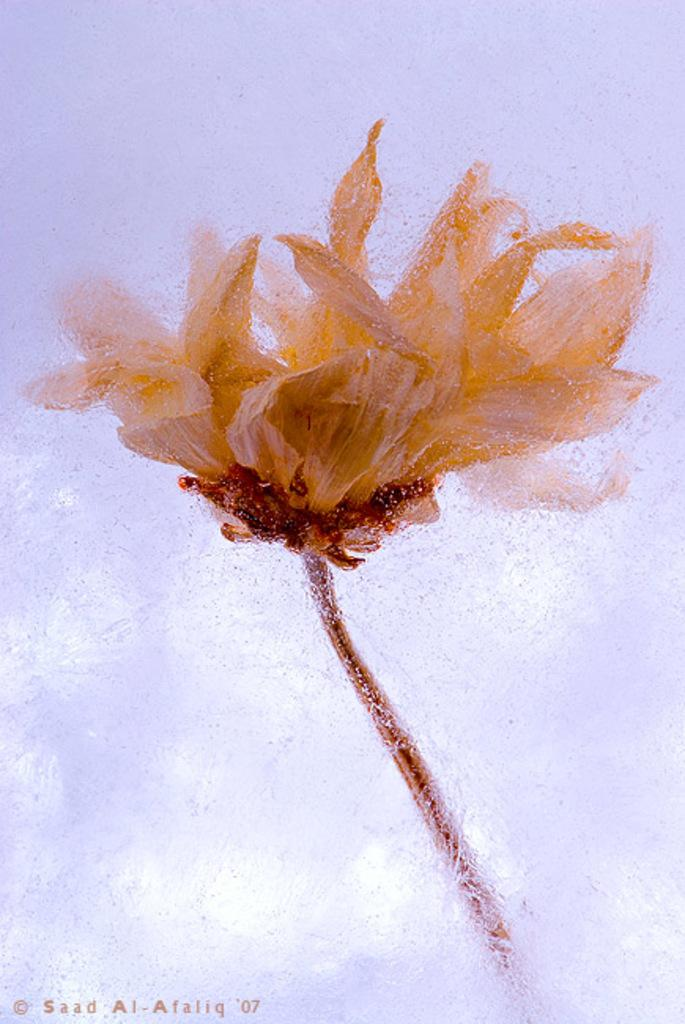What is inside the water in the image? There is a flower inside the water in the image. What can be seen on the left side of the image? There is some text written on the left side of the image. What type of collar can be seen on the flower in the image? There is no collar present on the flower in the image. Is there a crate visible in the image? There is no crate present in the image. 